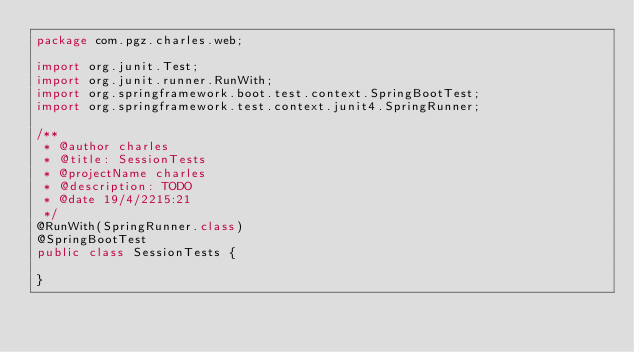<code> <loc_0><loc_0><loc_500><loc_500><_Java_>package com.pgz.charles.web;

import org.junit.Test;
import org.junit.runner.RunWith;
import org.springframework.boot.test.context.SpringBootTest;
import org.springframework.test.context.junit4.SpringRunner;

/**
 * @author charles
 * @title: SessionTests
 * @projectName charles
 * @description: TODO
 * @date 19/4/2215:21
 */
@RunWith(SpringRunner.class)
@SpringBootTest
public class SessionTests {

}
</code> 